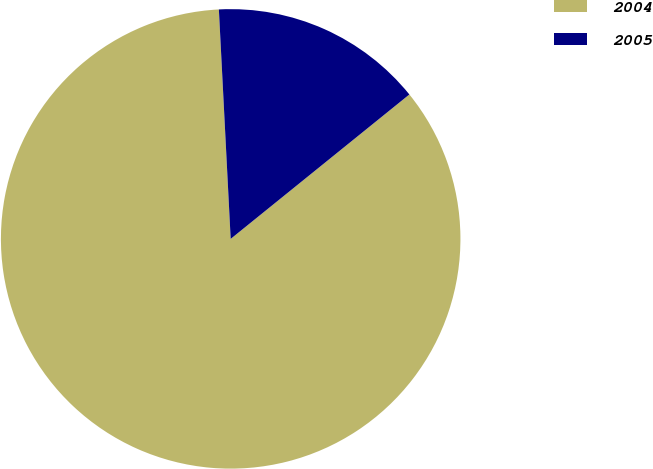<chart> <loc_0><loc_0><loc_500><loc_500><pie_chart><fcel>2004<fcel>2005<nl><fcel>85.0%<fcel>15.0%<nl></chart> 